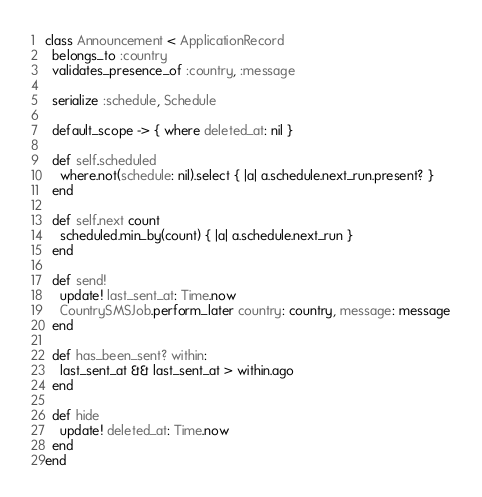Convert code to text. <code><loc_0><loc_0><loc_500><loc_500><_Ruby_>class Announcement < ApplicationRecord
  belongs_to :country
  validates_presence_of :country, :message

  serialize :schedule, Schedule

  default_scope -> { where deleted_at: nil }

  def self.scheduled
    where.not(schedule: nil).select { |a| a.schedule.next_run.present? }
  end

  def self.next count
    scheduled.min_by(count) { |a| a.schedule.next_run }
  end

  def send!
    update! last_sent_at: Time.now
    CountrySMSJob.perform_later country: country, message: message
  end

  def has_been_sent? within:
    last_sent_at && last_sent_at > within.ago
  end

  def hide
    update! deleted_at: Time.now
  end
end
</code> 